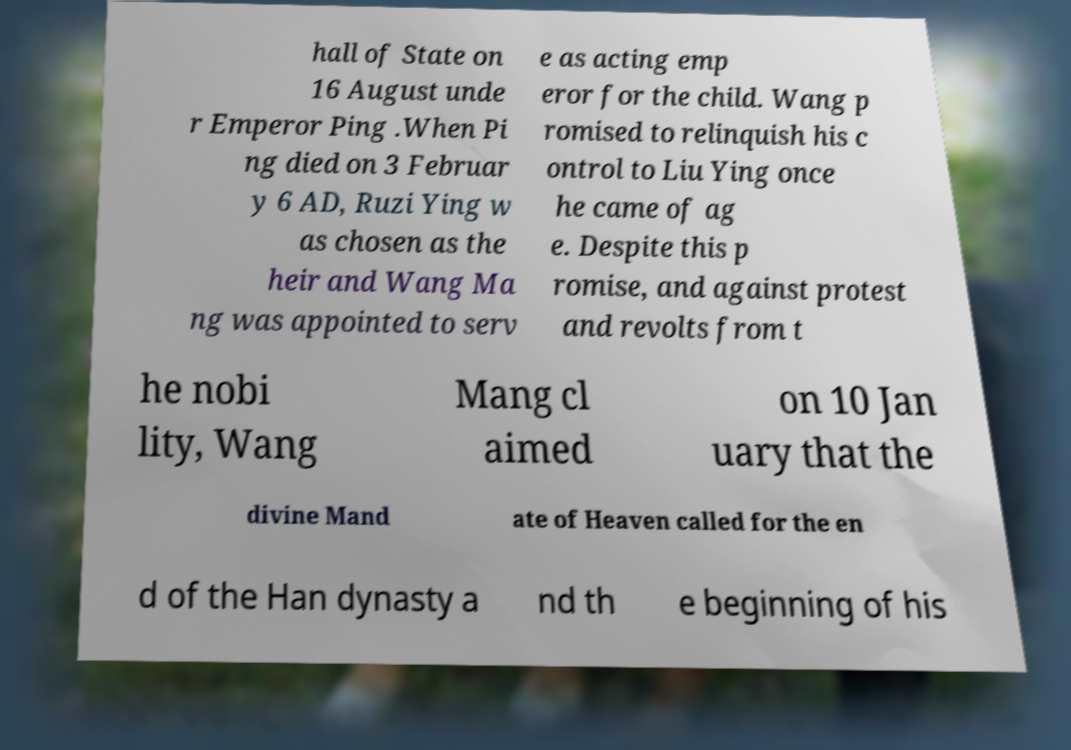I need the written content from this picture converted into text. Can you do that? hall of State on 16 August unde r Emperor Ping .When Pi ng died on 3 Februar y 6 AD, Ruzi Ying w as chosen as the heir and Wang Ma ng was appointed to serv e as acting emp eror for the child. Wang p romised to relinquish his c ontrol to Liu Ying once he came of ag e. Despite this p romise, and against protest and revolts from t he nobi lity, Wang Mang cl aimed on 10 Jan uary that the divine Mand ate of Heaven called for the en d of the Han dynasty a nd th e beginning of his 